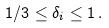<formula> <loc_0><loc_0><loc_500><loc_500>1 / 3 \leq \delta _ { i } \leq 1 \, .</formula> 